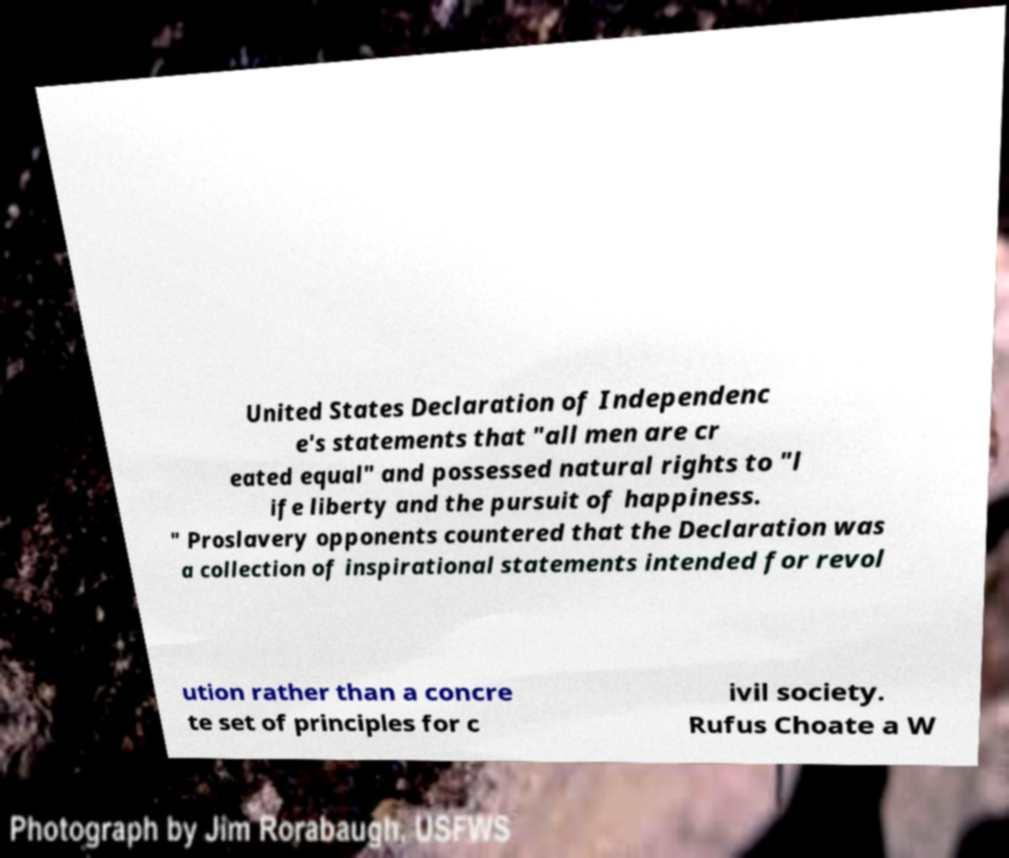Can you accurately transcribe the text from the provided image for me? United States Declaration of Independenc e's statements that "all men are cr eated equal" and possessed natural rights to "l ife liberty and the pursuit of happiness. " Proslavery opponents countered that the Declaration was a collection of inspirational statements intended for revol ution rather than a concre te set of principles for c ivil society. Rufus Choate a W 